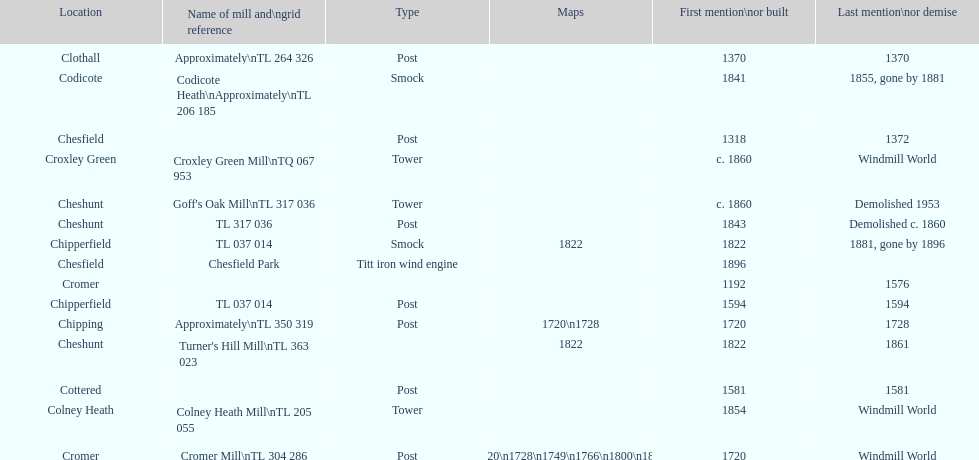How many locations have no photograph? 14. 